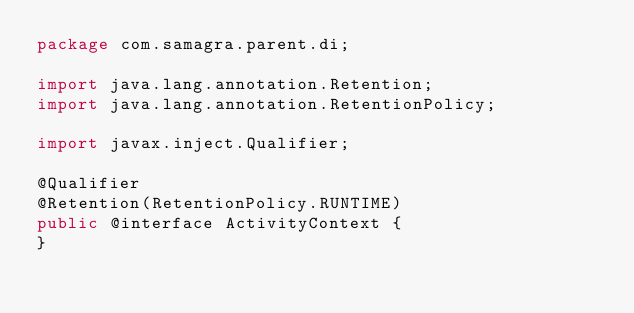<code> <loc_0><loc_0><loc_500><loc_500><_Java_>package com.samagra.parent.di;

import java.lang.annotation.Retention;
import java.lang.annotation.RetentionPolicy;

import javax.inject.Qualifier;

@Qualifier
@Retention(RetentionPolicy.RUNTIME)
public @interface ActivityContext {
}
</code> 